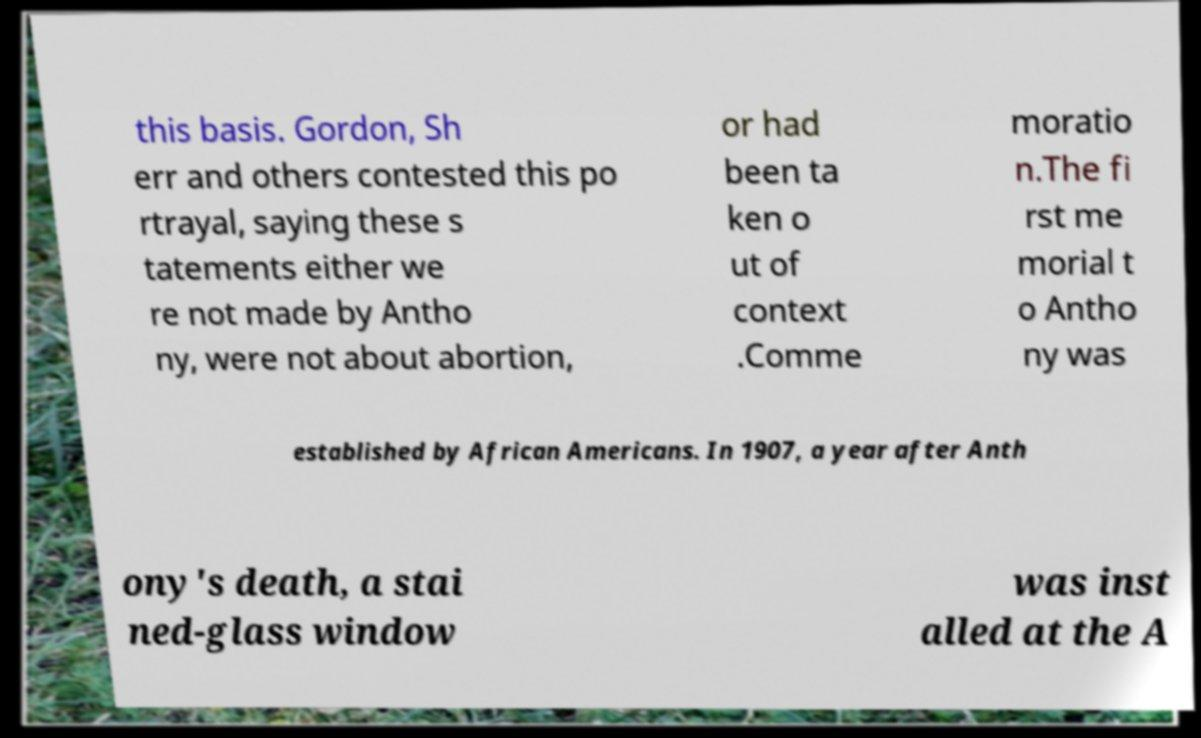Could you extract and type out the text from this image? this basis. Gordon, Sh err and others contested this po rtrayal, saying these s tatements either we re not made by Antho ny, were not about abortion, or had been ta ken o ut of context .Comme moratio n.The fi rst me morial t o Antho ny was established by African Americans. In 1907, a year after Anth ony's death, a stai ned-glass window was inst alled at the A 